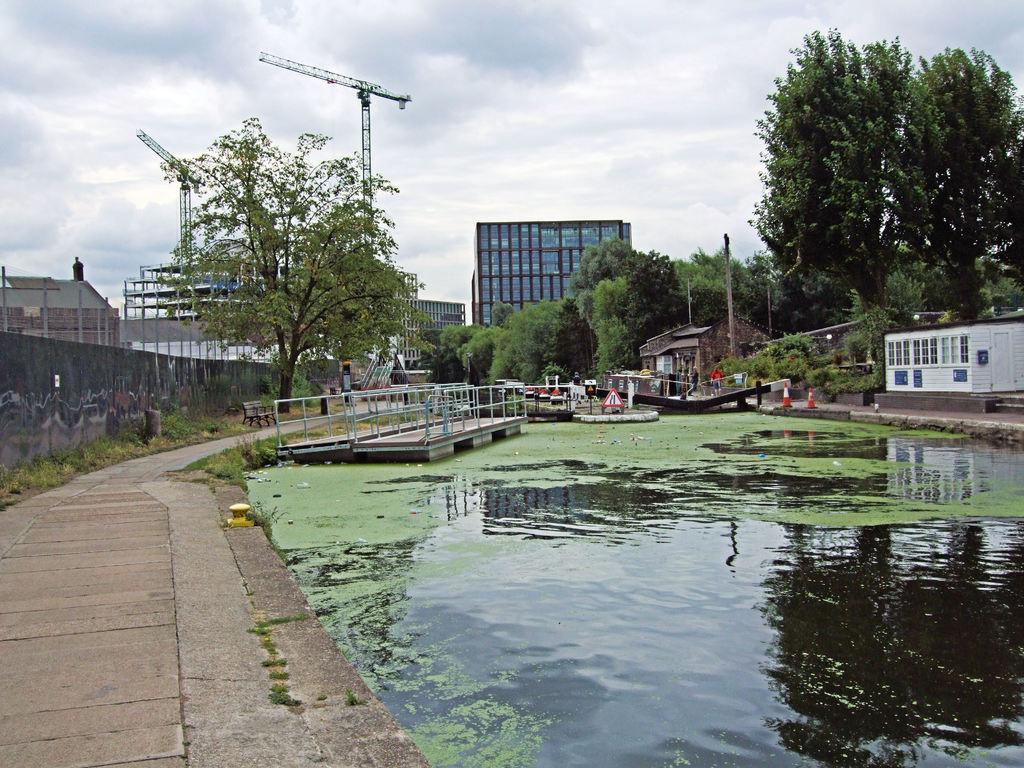How would you summarize this image in a sentence or two? In this image we can see a pond and pavement. Background of the image trees and buildings are present. The sky is covered with clouds. 